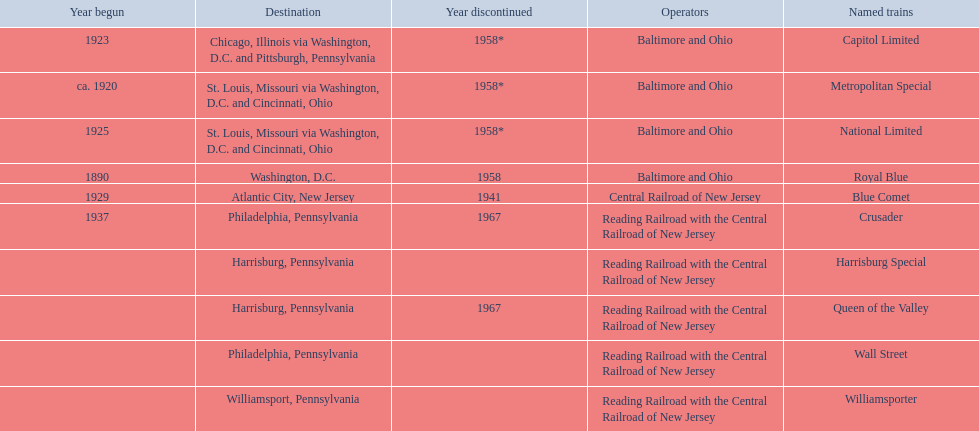What are the destinations of the central railroad of new jersey terminal? Chicago, Illinois via Washington, D.C. and Pittsburgh, Pennsylvania, St. Louis, Missouri via Washington, D.C. and Cincinnati, Ohio, St. Louis, Missouri via Washington, D.C. and Cincinnati, Ohio, Washington, D.C., Atlantic City, New Jersey, Philadelphia, Pennsylvania, Harrisburg, Pennsylvania, Harrisburg, Pennsylvania, Philadelphia, Pennsylvania, Williamsport, Pennsylvania. Which of these destinations is at the top of the list? Chicago, Illinois via Washington, D.C. and Pittsburgh, Pennsylvania. 